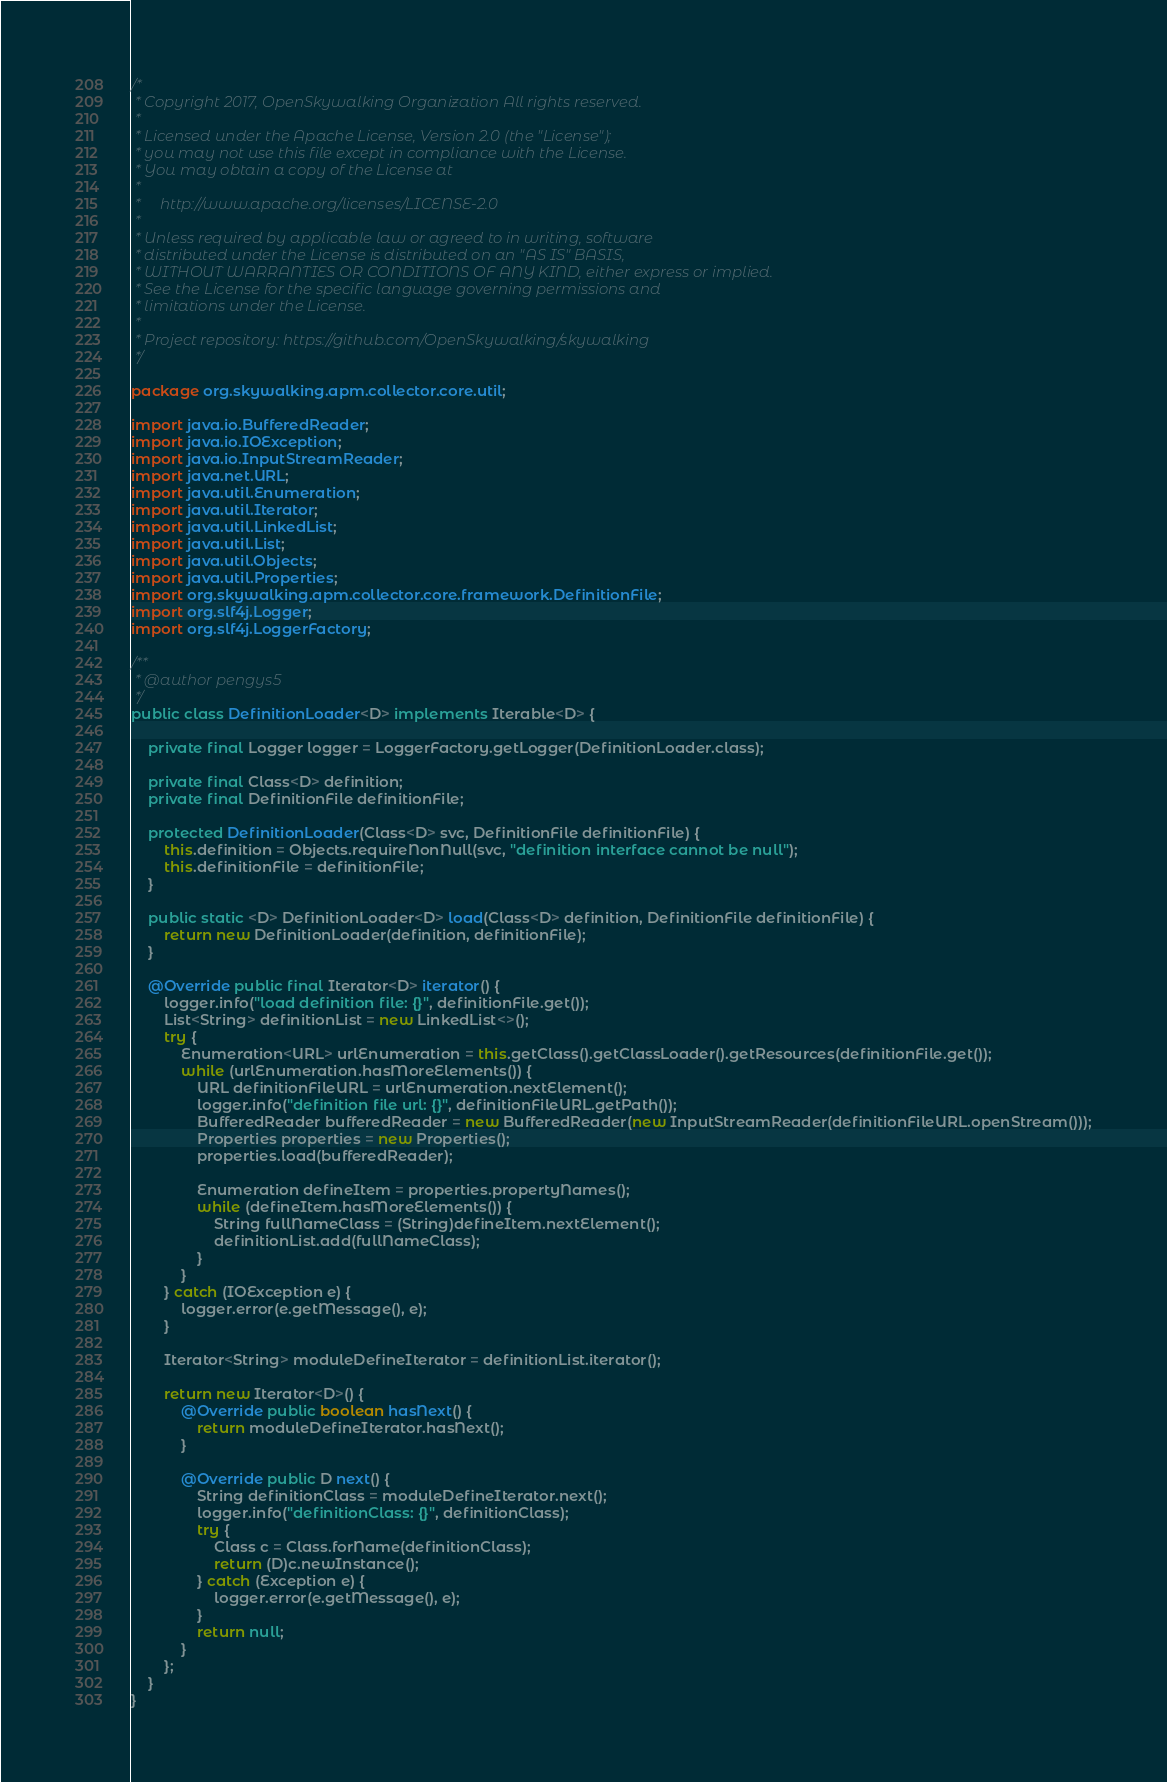Convert code to text. <code><loc_0><loc_0><loc_500><loc_500><_Java_>/*
 * Copyright 2017, OpenSkywalking Organization All rights reserved.
 *
 * Licensed under the Apache License, Version 2.0 (the "License");
 * you may not use this file except in compliance with the License.
 * You may obtain a copy of the License at
 *
 *     http://www.apache.org/licenses/LICENSE-2.0
 *
 * Unless required by applicable law or agreed to in writing, software
 * distributed under the License is distributed on an "AS IS" BASIS,
 * WITHOUT WARRANTIES OR CONDITIONS OF ANY KIND, either express or implied.
 * See the License for the specific language governing permissions and
 * limitations under the License.
 *
 * Project repository: https://github.com/OpenSkywalking/skywalking
 */

package org.skywalking.apm.collector.core.util;

import java.io.BufferedReader;
import java.io.IOException;
import java.io.InputStreamReader;
import java.net.URL;
import java.util.Enumeration;
import java.util.Iterator;
import java.util.LinkedList;
import java.util.List;
import java.util.Objects;
import java.util.Properties;
import org.skywalking.apm.collector.core.framework.DefinitionFile;
import org.slf4j.Logger;
import org.slf4j.LoggerFactory;

/**
 * @author pengys5
 */
public class DefinitionLoader<D> implements Iterable<D> {

    private final Logger logger = LoggerFactory.getLogger(DefinitionLoader.class);

    private final Class<D> definition;
    private final DefinitionFile definitionFile;

    protected DefinitionLoader(Class<D> svc, DefinitionFile definitionFile) {
        this.definition = Objects.requireNonNull(svc, "definition interface cannot be null");
        this.definitionFile = definitionFile;
    }

    public static <D> DefinitionLoader<D> load(Class<D> definition, DefinitionFile definitionFile) {
        return new DefinitionLoader(definition, definitionFile);
    }

    @Override public final Iterator<D> iterator() {
        logger.info("load definition file: {}", definitionFile.get());
        List<String> definitionList = new LinkedList<>();
        try {
            Enumeration<URL> urlEnumeration = this.getClass().getClassLoader().getResources(definitionFile.get());
            while (urlEnumeration.hasMoreElements()) {
                URL definitionFileURL = urlEnumeration.nextElement();
                logger.info("definition file url: {}", definitionFileURL.getPath());
                BufferedReader bufferedReader = new BufferedReader(new InputStreamReader(definitionFileURL.openStream()));
                Properties properties = new Properties();
                properties.load(bufferedReader);

                Enumeration defineItem = properties.propertyNames();
                while (defineItem.hasMoreElements()) {
                    String fullNameClass = (String)defineItem.nextElement();
                    definitionList.add(fullNameClass);
                }
            }
        } catch (IOException e) {
            logger.error(e.getMessage(), e);
        }

        Iterator<String> moduleDefineIterator = definitionList.iterator();

        return new Iterator<D>() {
            @Override public boolean hasNext() {
                return moduleDefineIterator.hasNext();
            }

            @Override public D next() {
                String definitionClass = moduleDefineIterator.next();
                logger.info("definitionClass: {}", definitionClass);
                try {
                    Class c = Class.forName(definitionClass);
                    return (D)c.newInstance();
                } catch (Exception e) {
                    logger.error(e.getMessage(), e);
                }
                return null;
            }
        };
    }
}
</code> 